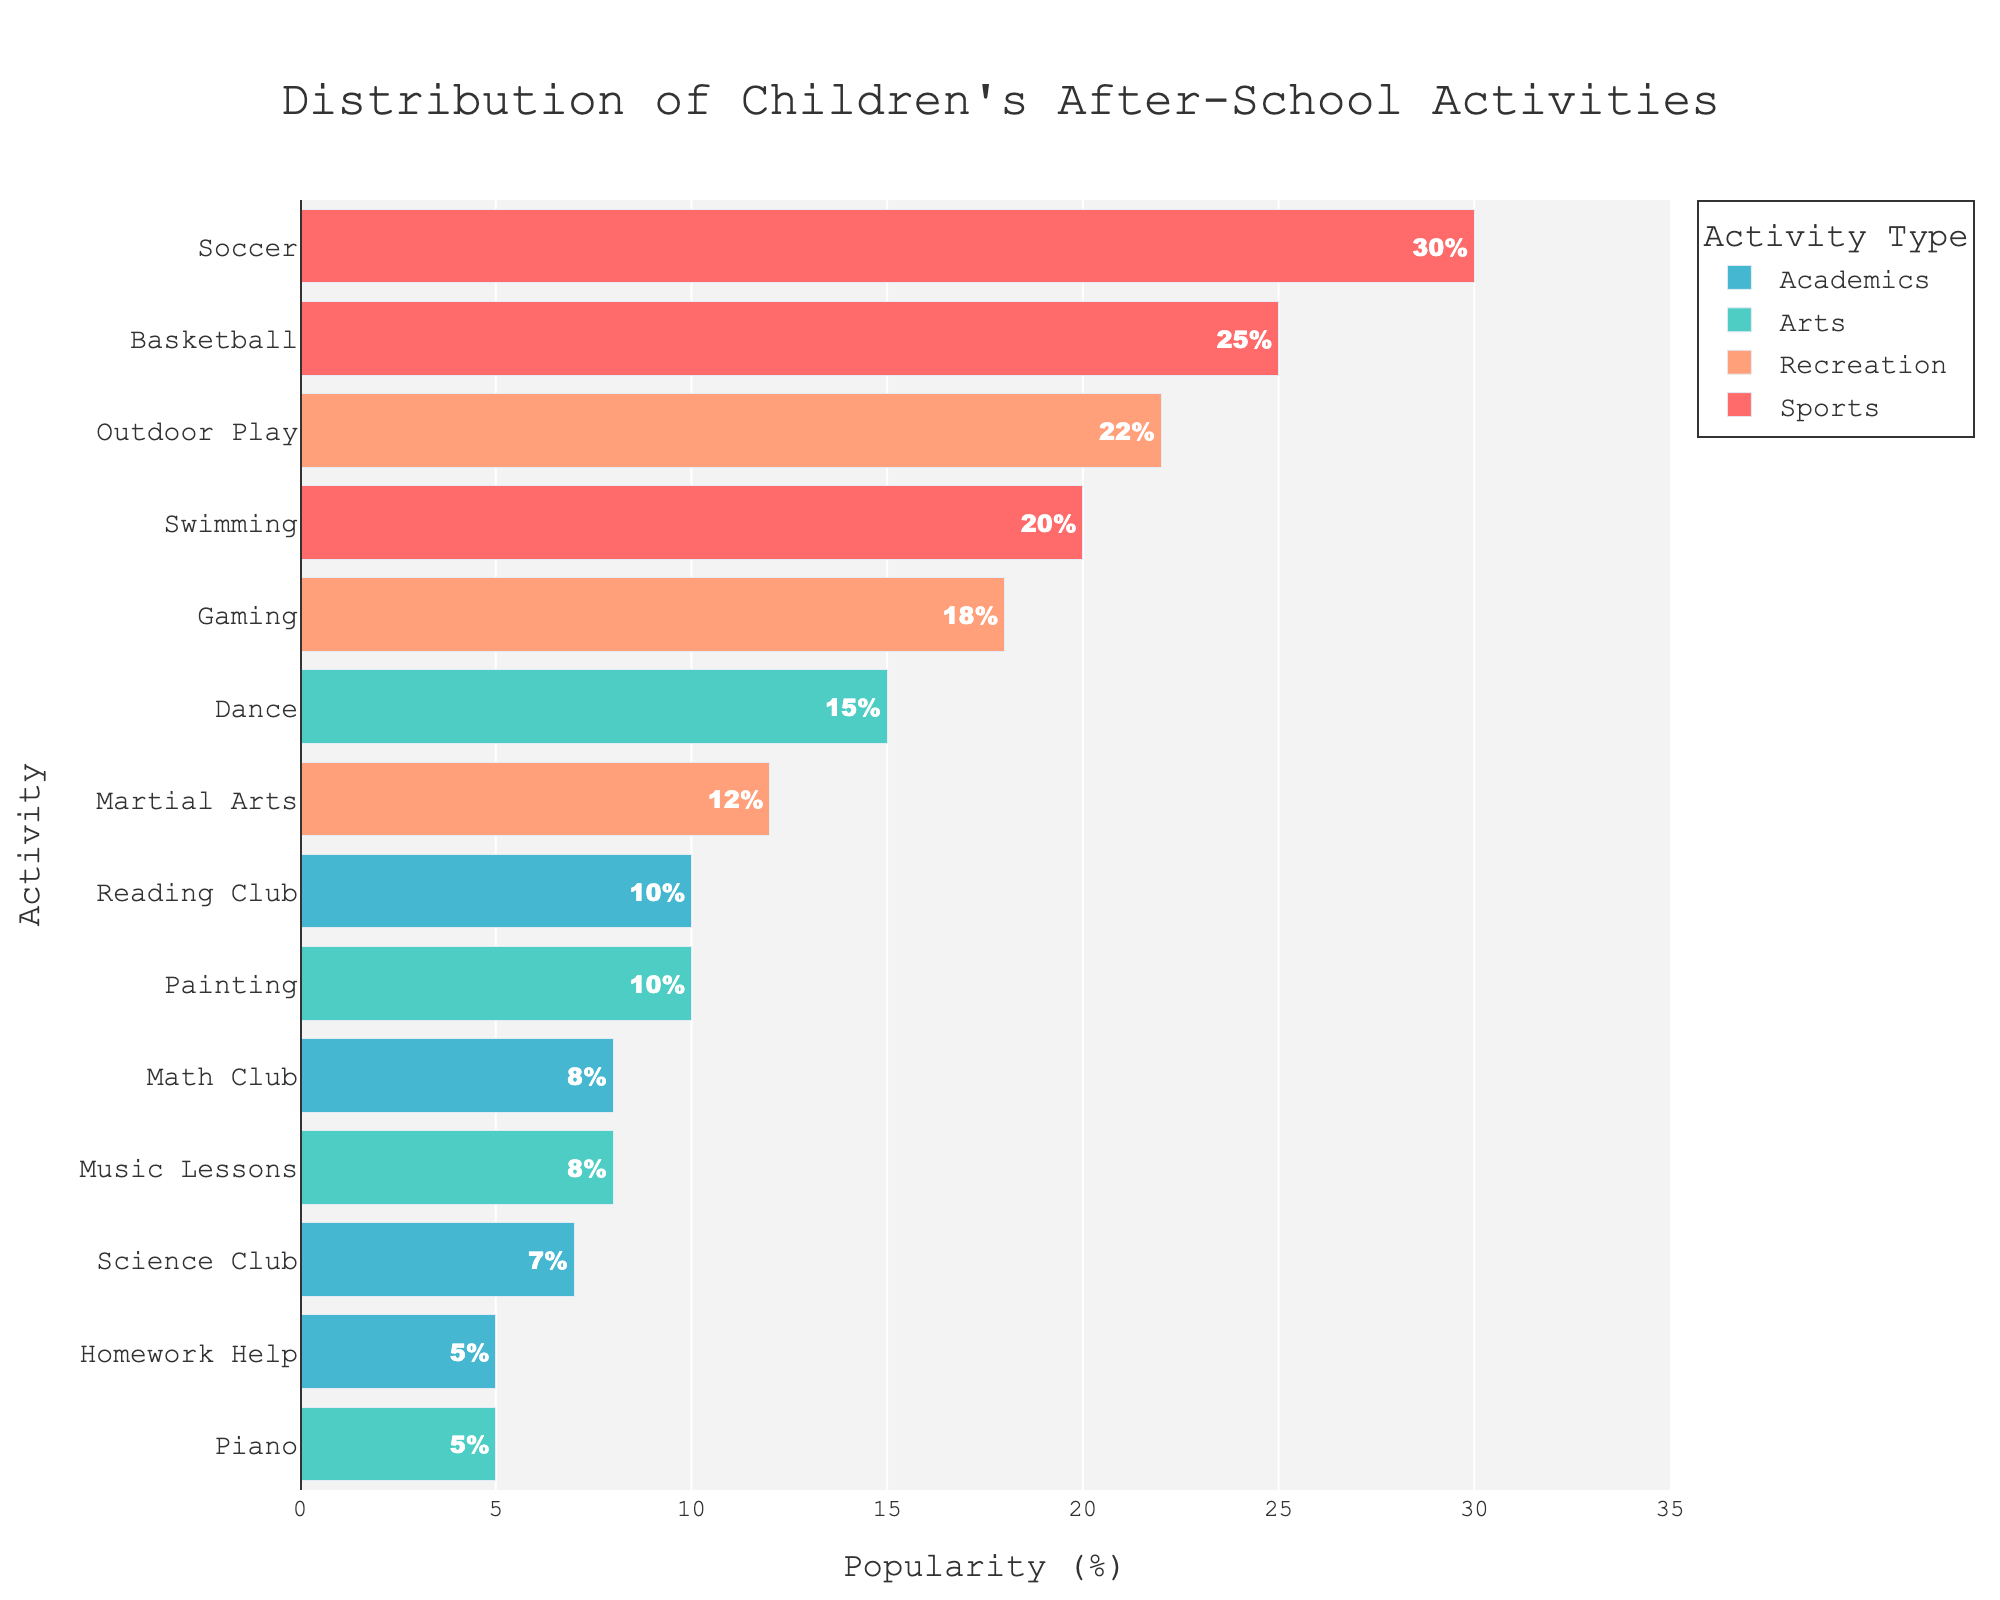what is the most popular after-school activity? The figure shows different after-school activities with varying popularity percentages. Soccer shows the highest bar in the Sports section.
Answer: Soccer Which type of activity has the highest overall popularity percentage? Examining the bars of different colors indicating the types, the Sports type, with Soccer, Basketball, and Swimming, has high popularity bars.
Answer: Sports What is the total popularity percentage of Arts activities? The popularity percentages for Arts activities (Dance, Painting, Piano, and Music Lessons) are 15%, 10%, 5%, and 8%. Adding them: 15% + 10% + 5% + 8% = 38%.
Answer: 38% Which type of activities have the least representation in the chart? Comparing the bars representing different types of activities, the Academic category (Reading Club, Math Club, Science Club, Homework Help) has shorter bars overall.
Answer: Academics Compare the popularity of 'Outdoor Play' and 'Dance'. Which is more popular? The figure shows a bar for Outdoor Play at 22% and a bar for Dance at 15%. Outdoor Play's bar is longer.
Answer: Outdoor Play What is the combined popularity percentage of 'Sports' and 'Recreation' activities? Summing up the popularity percentages for Sports (30% + 25% + 20%) and Recreation (18% + 12% + 22%): (30% + 25% + 20%) + (18% + 12% + 22%) = 75% + 52% = 127%.
Answer: 127% Which activity has the same popularity as 'Gaming'? The bar length and percentage indicate 'Gaming' has an 18% popularity. By matching to another bar, 'Outdoor Play' also has an 18% popularity.
Answer: Outdoor Play Between 'Painting' and 'Science Club', which has a lower popularity? The figure shows 'Painting' with 10% popularity and 'Science Club' with 7%. The shorter bar indicates 'Science Club' is lower.
Answer: Science Club What is the percentage difference between 'Basketball' and 'Math Club'? Basketball has a 25% popularity, and Math Club has 8%. The difference is 25% - 8% = 17%.
Answer: 17% What color is used to represent the 'Recreation' category? Observation shows bars for 'Recreation' activities (Gaming, Martial Arts, and Outdoor Play) are shaded in a similar color (orange).
Answer: Orange 